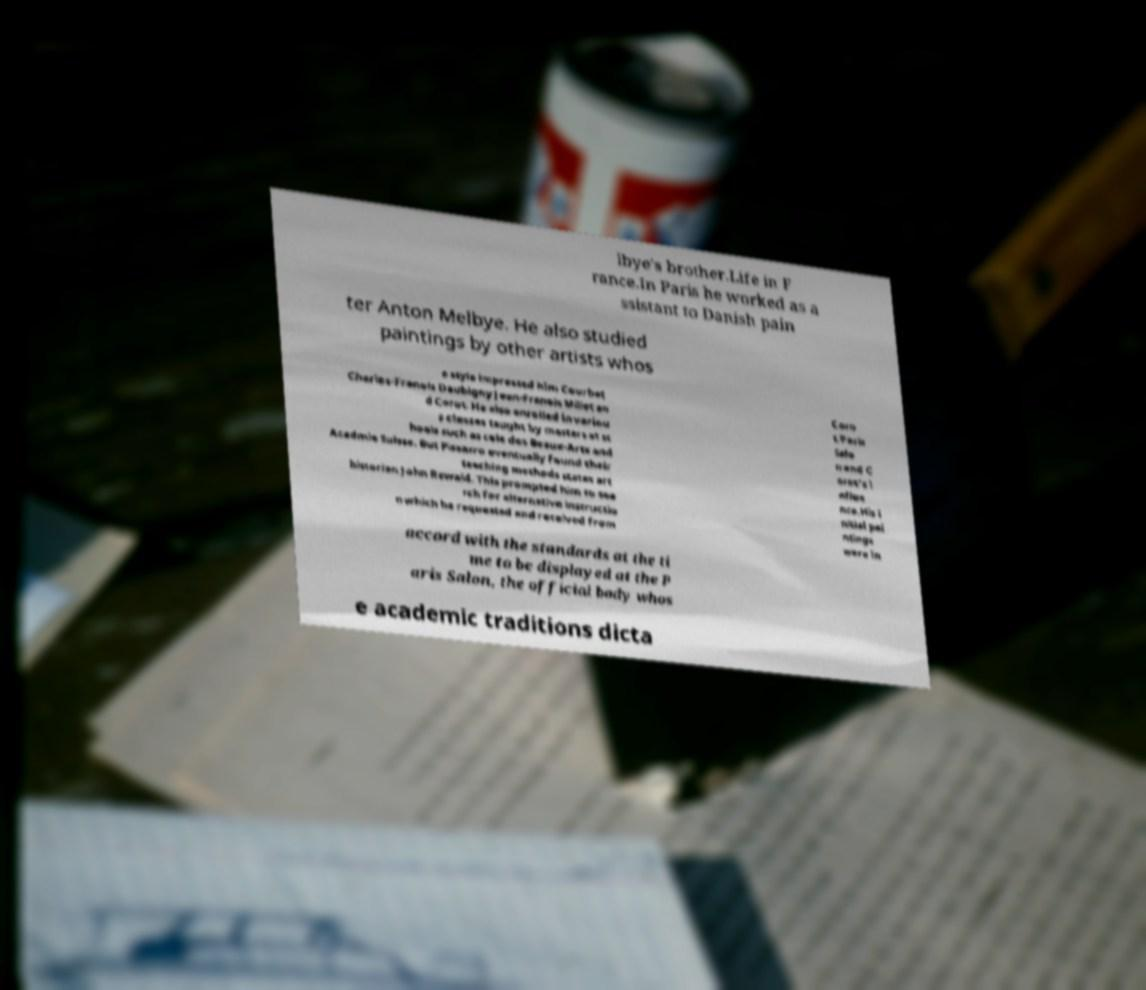I need the written content from this picture converted into text. Can you do that? lbye's brother.Life in F rance.In Paris he worked as a ssistant to Danish pain ter Anton Melbye. He also studied paintings by other artists whos e style impressed him Courbet Charles-Franois Daubigny Jean-Franois Millet an d Corot. He also enrolled in variou s classes taught by masters at sc hools such as cole des Beaux-Arts and Acadmie Suisse. But Pissarro eventually found their teaching methods states art historian John Rewald. This prompted him to sea rch for alternative instructio n which he requested and received from Coro t.Paris Salo n and C orot's i nflue nce.His i nitial pai ntings were in accord with the standards at the ti me to be displayed at the P aris Salon, the official body whos e academic traditions dicta 